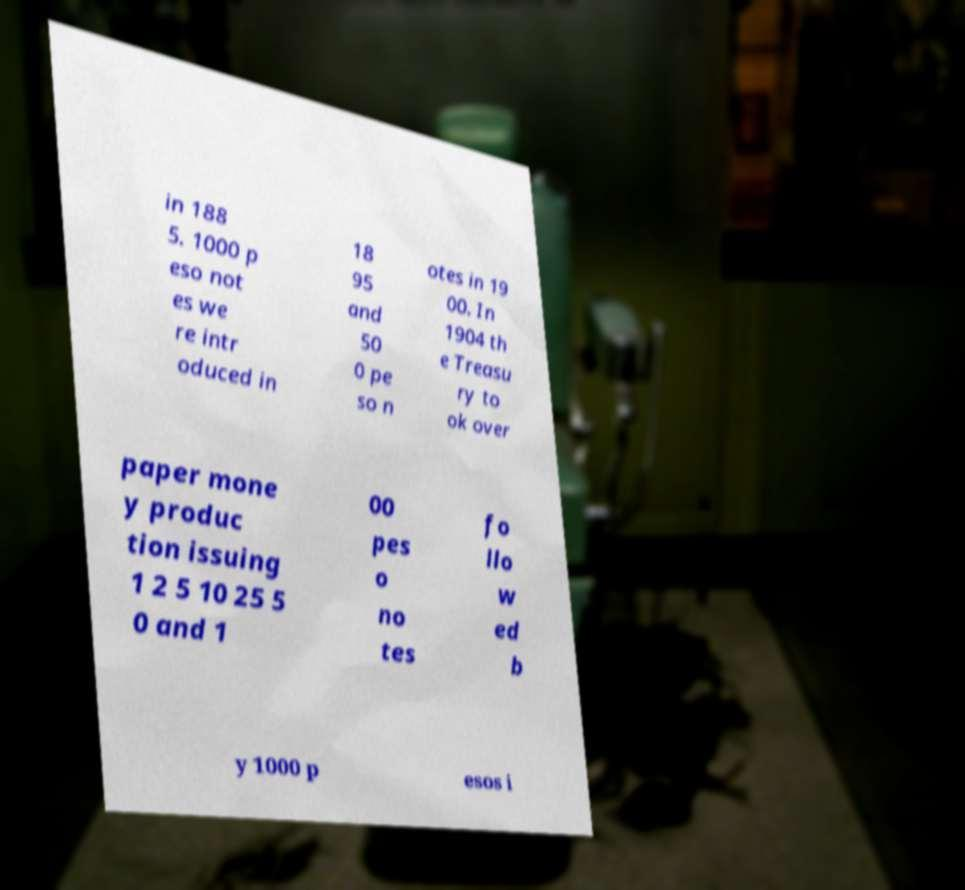Please identify and transcribe the text found in this image. in 188 5. 1000 p eso not es we re intr oduced in 18 95 and 50 0 pe so n otes in 19 00. In 1904 th e Treasu ry to ok over paper mone y produc tion issuing 1 2 5 10 25 5 0 and 1 00 pes o no tes fo llo w ed b y 1000 p esos i 